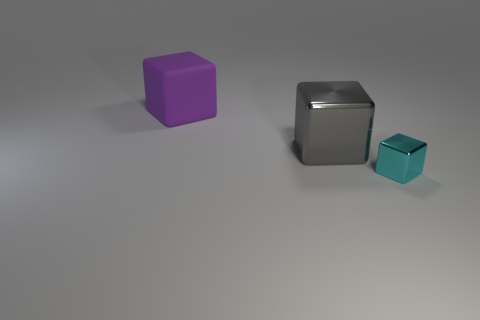Subtract all big cubes. How many cubes are left? 1 Add 1 large purple things. How many objects exist? 4 Subtract all gray blocks. How many blocks are left? 2 Subtract 3 cubes. How many cubes are left? 0 Subtract all brown blocks. Subtract all blue cylinders. How many blocks are left? 3 Subtract all spheres. Subtract all big rubber things. How many objects are left? 2 Add 1 gray metallic cubes. How many gray metallic cubes are left? 2 Add 3 purple matte cubes. How many purple matte cubes exist? 4 Subtract 0 gray cylinders. How many objects are left? 3 